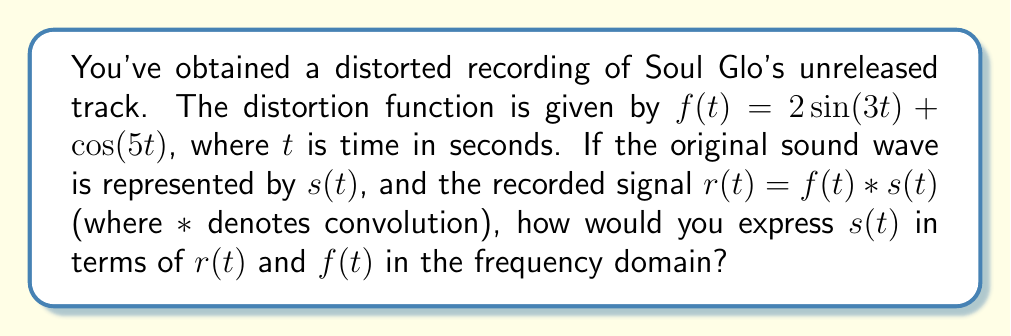Provide a solution to this math problem. To solve this inverse problem and recover the original sound wave, we'll follow these steps:

1) First, recall that convolution in the time domain corresponds to multiplication in the frequency domain. Let's denote the Fourier transforms of $r(t)$, $f(t)$, and $s(t)$ as $R(\omega)$, $F(\omega)$, and $S(\omega)$ respectively.

2) In the frequency domain, we can express the relationship as:

   $R(\omega) = F(\omega) \cdot S(\omega)$

3) To isolate $S(\omega)$, we need to divide both sides by $F(\omega)$:

   $S(\omega) = \frac{R(\omega)}{F(\omega)}$

4) However, we need to be careful about division by zero. In practice, we'd use regularization techniques to handle frequencies where $F(\omega)$ is zero or very small.

5) The expression $\frac{R(\omega)}{F(\omega)}$ is known as the inverse filter in the frequency domain.

6) To get back to the time domain, we would need to apply the inverse Fourier transform to $S(\omega)$:

   $s(t) = \mathcal{F}^{-1}\left\{\frac{R(\omega)}{F(\omega)}\right\}$

This expression represents the solution to our inverse problem in the frequency domain.
Answer: $S(\omega) = \frac{R(\omega)}{F(\omega)}$ 